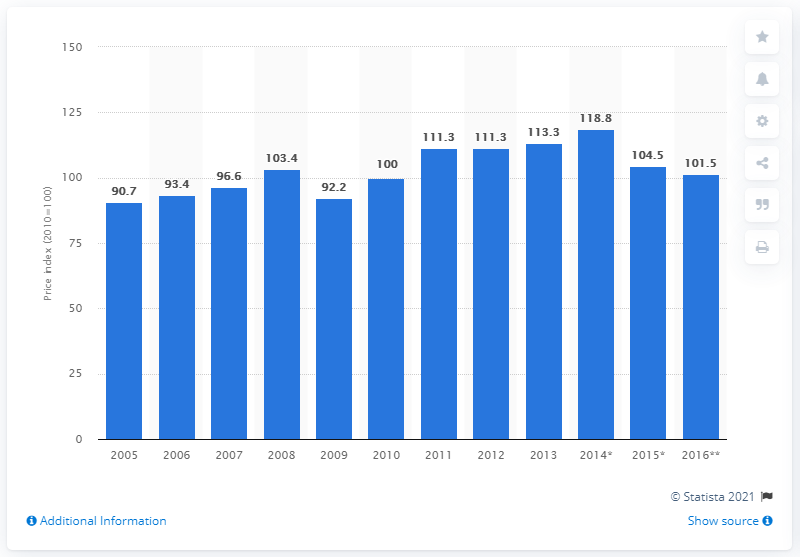Draw attention to some important aspects in this diagram. The price index of industrial chemicals in 2011 was 111.3. 